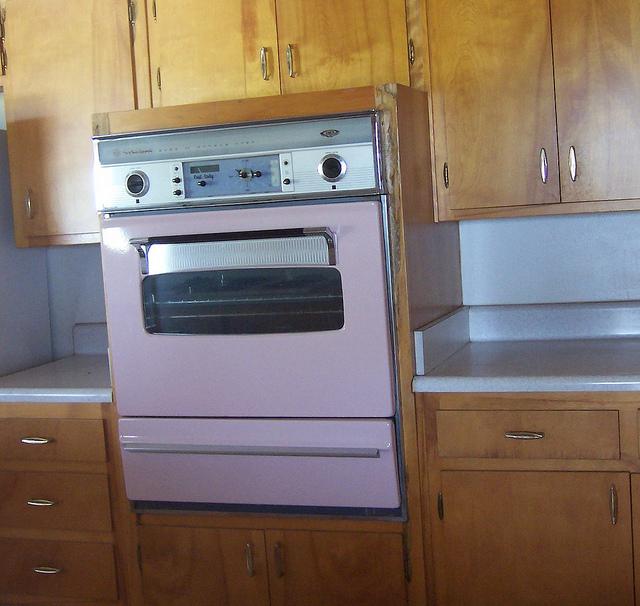Are the countertops empty?
Write a very short answer. Yes. Does this oven have a stovetop?
Write a very short answer. No. What color are the cabinets?
Give a very brief answer. Brown. What color is the oven?
Write a very short answer. Pink. Is this an electric oven?
Quick response, please. Yes. 